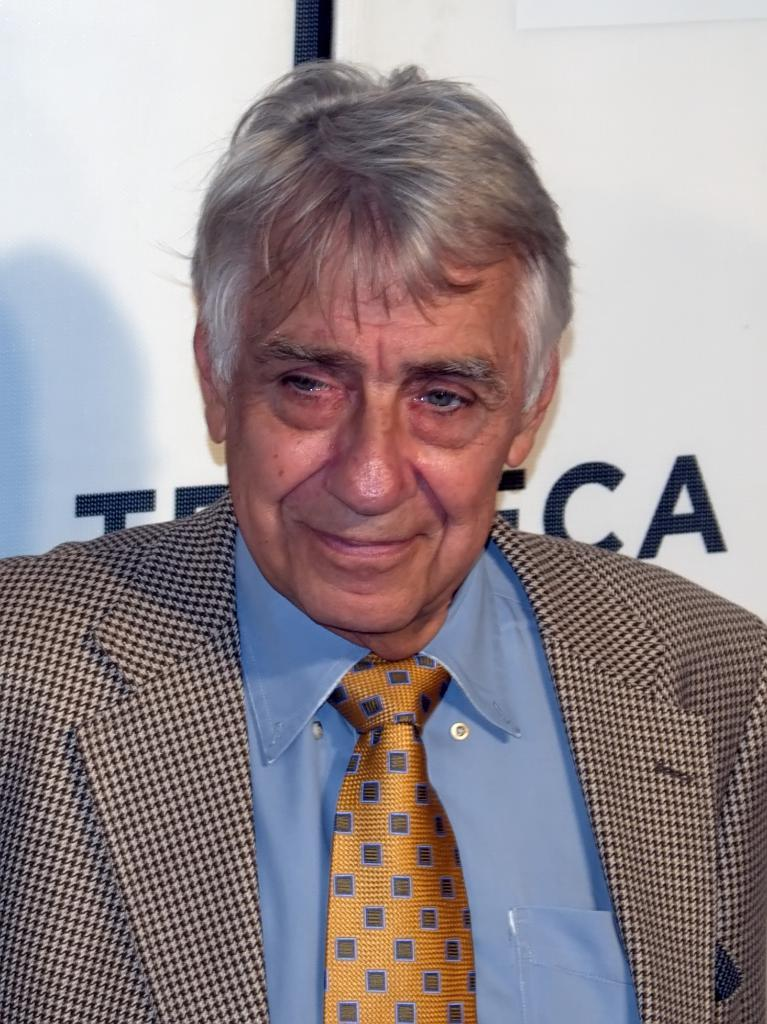Who or what is the main subject in the image? There is a person in the center of the image. Can you describe the person's attire? The person is wearing a coat and a tie. What can be seen in the background of the image? There is a banner in the background of the image. What information is provided on the banner? There is text visible on the banner. What grade does the appliance receive in the image? There is no appliance present in the image, so it cannot receive a grade. 